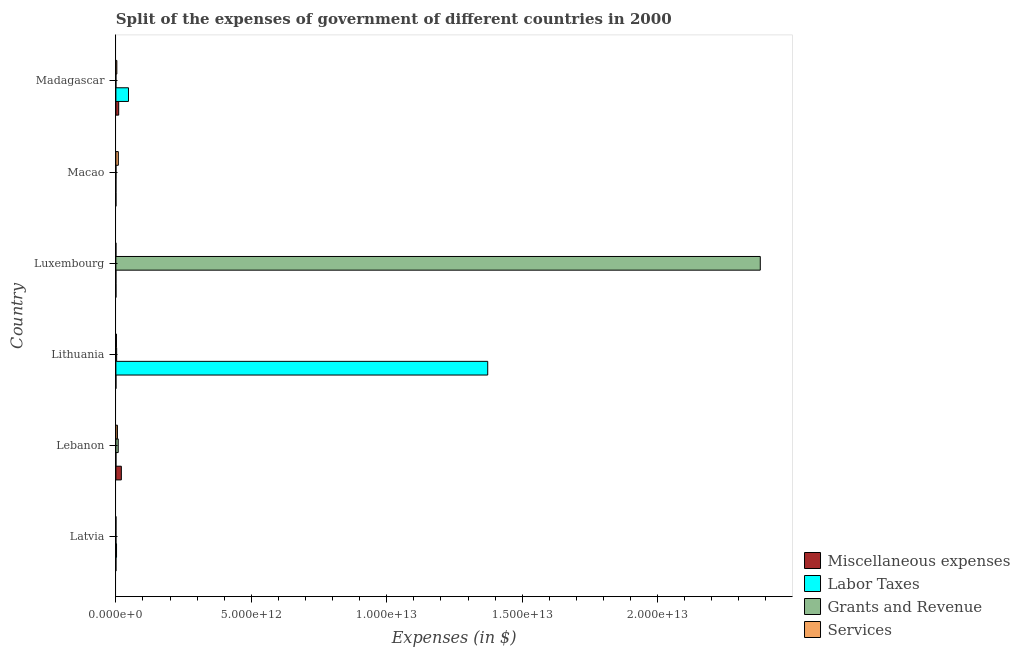How many different coloured bars are there?
Offer a terse response. 4. How many groups of bars are there?
Offer a very short reply. 6. What is the label of the 6th group of bars from the top?
Offer a terse response. Latvia. What is the amount spent on miscellaneous expenses in Madagascar?
Provide a succinct answer. 1.03e+11. Across all countries, what is the maximum amount spent on services?
Your answer should be very brief. 9.03e+1. In which country was the amount spent on services maximum?
Keep it short and to the point. Macao. In which country was the amount spent on miscellaneous expenses minimum?
Keep it short and to the point. Latvia. What is the total amount spent on grants and revenue in the graph?
Your response must be concise. 2.39e+13. What is the difference between the amount spent on services in Latvia and that in Lebanon?
Your answer should be compact. -5.52e+1. What is the difference between the amount spent on services in Latvia and the amount spent on labor taxes in Madagascar?
Keep it short and to the point. -4.63e+11. What is the average amount spent on services per country?
Make the answer very short. 3.40e+1. What is the difference between the amount spent on grants and revenue and amount spent on services in Macao?
Your answer should be very brief. -8.81e+1. What is the ratio of the amount spent on grants and revenue in Latvia to that in Lithuania?
Your answer should be compact. 0.02. Is the amount spent on services in Lithuania less than that in Madagascar?
Offer a terse response. Yes. Is the difference between the amount spent on grants and revenue in Latvia and Lithuania greater than the difference between the amount spent on services in Latvia and Lithuania?
Your response must be concise. No. What is the difference between the highest and the second highest amount spent on labor taxes?
Your response must be concise. 1.33e+13. What is the difference between the highest and the lowest amount spent on miscellaneous expenses?
Offer a very short reply. 2.01e+11. In how many countries, is the amount spent on services greater than the average amount spent on services taken over all countries?
Provide a succinct answer. 3. Is the sum of the amount spent on services in Latvia and Luxembourg greater than the maximum amount spent on grants and revenue across all countries?
Your answer should be very brief. No. Is it the case that in every country, the sum of the amount spent on grants and revenue and amount spent on services is greater than the sum of amount spent on labor taxes and amount spent on miscellaneous expenses?
Offer a very short reply. No. What does the 2nd bar from the top in Lithuania represents?
Your answer should be very brief. Grants and Revenue. What does the 1st bar from the bottom in Madagascar represents?
Provide a short and direct response. Miscellaneous expenses. How many bars are there?
Provide a short and direct response. 24. How many countries are there in the graph?
Your answer should be very brief. 6. What is the difference between two consecutive major ticks on the X-axis?
Your answer should be compact. 5.00e+12. Where does the legend appear in the graph?
Provide a succinct answer. Bottom right. What is the title of the graph?
Offer a very short reply. Split of the expenses of government of different countries in 2000. Does "Overall level" appear as one of the legend labels in the graph?
Ensure brevity in your answer.  No. What is the label or title of the X-axis?
Make the answer very short. Expenses (in $). What is the label or title of the Y-axis?
Offer a very short reply. Country. What is the Expenses (in $) of Miscellaneous expenses in Latvia?
Your response must be concise. 6.00e+07. What is the Expenses (in $) of Labor Taxes in Latvia?
Provide a succinct answer. 2.39e+1. What is the Expenses (in $) of Grants and Revenue in Latvia?
Your answer should be compact. 6.04e+08. What is the Expenses (in $) in Services in Latvia?
Your answer should be very brief. 1.85e+09. What is the Expenses (in $) of Miscellaneous expenses in Lebanon?
Offer a terse response. 2.01e+11. What is the Expenses (in $) of Labor Taxes in Lebanon?
Ensure brevity in your answer.  8.72e+08. What is the Expenses (in $) in Grants and Revenue in Lebanon?
Offer a very short reply. 8.59e+1. What is the Expenses (in $) of Services in Lebanon?
Offer a very short reply. 5.70e+1. What is the Expenses (in $) of Miscellaneous expenses in Lithuania?
Your answer should be compact. 1.35e+09. What is the Expenses (in $) of Labor Taxes in Lithuania?
Keep it short and to the point. 1.37e+13. What is the Expenses (in $) of Grants and Revenue in Lithuania?
Your answer should be compact. 2.80e+1. What is the Expenses (in $) in Services in Lithuania?
Keep it short and to the point. 2.03e+1. What is the Expenses (in $) of Miscellaneous expenses in Luxembourg?
Keep it short and to the point. 9.61e+08. What is the Expenses (in $) in Labor Taxes in Luxembourg?
Give a very brief answer. 2.00e+05. What is the Expenses (in $) in Grants and Revenue in Luxembourg?
Keep it short and to the point. 2.38e+13. What is the Expenses (in $) in Services in Luxembourg?
Offer a very short reply. 1.02e+08. What is the Expenses (in $) of Miscellaneous expenses in Macao?
Provide a succinct answer. 1.19e+09. What is the Expenses (in $) in Grants and Revenue in Macao?
Ensure brevity in your answer.  2.19e+09. What is the Expenses (in $) of Services in Macao?
Your answer should be compact. 9.03e+1. What is the Expenses (in $) in Miscellaneous expenses in Madagascar?
Provide a short and direct response. 1.03e+11. What is the Expenses (in $) in Labor Taxes in Madagascar?
Offer a terse response. 4.65e+11. What is the Expenses (in $) of Grants and Revenue in Madagascar?
Your response must be concise. 1.68e+08. What is the Expenses (in $) in Services in Madagascar?
Offer a very short reply. 3.46e+1. Across all countries, what is the maximum Expenses (in $) of Miscellaneous expenses?
Provide a succinct answer. 2.01e+11. Across all countries, what is the maximum Expenses (in $) of Labor Taxes?
Give a very brief answer. 1.37e+13. Across all countries, what is the maximum Expenses (in $) of Grants and Revenue?
Your response must be concise. 2.38e+13. Across all countries, what is the maximum Expenses (in $) in Services?
Keep it short and to the point. 9.03e+1. Across all countries, what is the minimum Expenses (in $) of Miscellaneous expenses?
Give a very brief answer. 6.00e+07. Across all countries, what is the minimum Expenses (in $) in Grants and Revenue?
Your answer should be very brief. 1.68e+08. Across all countries, what is the minimum Expenses (in $) in Services?
Provide a succinct answer. 1.02e+08. What is the total Expenses (in $) in Miscellaneous expenses in the graph?
Your response must be concise. 3.08e+11. What is the total Expenses (in $) of Labor Taxes in the graph?
Offer a terse response. 1.42e+13. What is the total Expenses (in $) of Grants and Revenue in the graph?
Your answer should be compact. 2.39e+13. What is the total Expenses (in $) of Services in the graph?
Keep it short and to the point. 2.04e+11. What is the difference between the Expenses (in $) of Miscellaneous expenses in Latvia and that in Lebanon?
Give a very brief answer. -2.01e+11. What is the difference between the Expenses (in $) in Labor Taxes in Latvia and that in Lebanon?
Offer a terse response. 2.30e+1. What is the difference between the Expenses (in $) of Grants and Revenue in Latvia and that in Lebanon?
Offer a very short reply. -8.53e+1. What is the difference between the Expenses (in $) in Services in Latvia and that in Lebanon?
Offer a very short reply. -5.52e+1. What is the difference between the Expenses (in $) in Miscellaneous expenses in Latvia and that in Lithuania?
Provide a short and direct response. -1.29e+09. What is the difference between the Expenses (in $) in Labor Taxes in Latvia and that in Lithuania?
Your answer should be compact. -1.37e+13. What is the difference between the Expenses (in $) of Grants and Revenue in Latvia and that in Lithuania?
Give a very brief answer. -2.74e+1. What is the difference between the Expenses (in $) of Services in Latvia and that in Lithuania?
Provide a succinct answer. -1.85e+1. What is the difference between the Expenses (in $) in Miscellaneous expenses in Latvia and that in Luxembourg?
Give a very brief answer. -9.01e+08. What is the difference between the Expenses (in $) in Labor Taxes in Latvia and that in Luxembourg?
Keep it short and to the point. 2.39e+1. What is the difference between the Expenses (in $) of Grants and Revenue in Latvia and that in Luxembourg?
Offer a very short reply. -2.38e+13. What is the difference between the Expenses (in $) in Services in Latvia and that in Luxembourg?
Your answer should be compact. 1.75e+09. What is the difference between the Expenses (in $) of Miscellaneous expenses in Latvia and that in Macao?
Your answer should be very brief. -1.13e+09. What is the difference between the Expenses (in $) in Labor Taxes in Latvia and that in Macao?
Offer a very short reply. 2.39e+1. What is the difference between the Expenses (in $) of Grants and Revenue in Latvia and that in Macao?
Ensure brevity in your answer.  -1.59e+09. What is the difference between the Expenses (in $) in Services in Latvia and that in Macao?
Ensure brevity in your answer.  -8.84e+1. What is the difference between the Expenses (in $) of Miscellaneous expenses in Latvia and that in Madagascar?
Provide a succinct answer. -1.03e+11. What is the difference between the Expenses (in $) in Labor Taxes in Latvia and that in Madagascar?
Keep it short and to the point. -4.41e+11. What is the difference between the Expenses (in $) in Grants and Revenue in Latvia and that in Madagascar?
Your response must be concise. 4.36e+08. What is the difference between the Expenses (in $) of Services in Latvia and that in Madagascar?
Offer a terse response. -3.28e+1. What is the difference between the Expenses (in $) of Miscellaneous expenses in Lebanon and that in Lithuania?
Make the answer very short. 2.00e+11. What is the difference between the Expenses (in $) of Labor Taxes in Lebanon and that in Lithuania?
Your answer should be very brief. -1.37e+13. What is the difference between the Expenses (in $) in Grants and Revenue in Lebanon and that in Lithuania?
Ensure brevity in your answer.  5.80e+1. What is the difference between the Expenses (in $) in Services in Lebanon and that in Lithuania?
Ensure brevity in your answer.  3.67e+1. What is the difference between the Expenses (in $) of Miscellaneous expenses in Lebanon and that in Luxembourg?
Make the answer very short. 2.00e+11. What is the difference between the Expenses (in $) of Labor Taxes in Lebanon and that in Luxembourg?
Your answer should be compact. 8.72e+08. What is the difference between the Expenses (in $) in Grants and Revenue in Lebanon and that in Luxembourg?
Keep it short and to the point. -2.37e+13. What is the difference between the Expenses (in $) of Services in Lebanon and that in Luxembourg?
Your answer should be very brief. 5.69e+1. What is the difference between the Expenses (in $) of Miscellaneous expenses in Lebanon and that in Macao?
Your response must be concise. 2.00e+11. What is the difference between the Expenses (in $) of Labor Taxes in Lebanon and that in Macao?
Ensure brevity in your answer.  8.72e+08. What is the difference between the Expenses (in $) of Grants and Revenue in Lebanon and that in Macao?
Give a very brief answer. 8.37e+1. What is the difference between the Expenses (in $) of Services in Lebanon and that in Macao?
Provide a short and direct response. -3.32e+1. What is the difference between the Expenses (in $) of Miscellaneous expenses in Lebanon and that in Madagascar?
Provide a short and direct response. 9.79e+1. What is the difference between the Expenses (in $) of Labor Taxes in Lebanon and that in Madagascar?
Your response must be concise. -4.64e+11. What is the difference between the Expenses (in $) in Grants and Revenue in Lebanon and that in Madagascar?
Keep it short and to the point. 8.57e+1. What is the difference between the Expenses (in $) in Services in Lebanon and that in Madagascar?
Give a very brief answer. 2.24e+1. What is the difference between the Expenses (in $) in Miscellaneous expenses in Lithuania and that in Luxembourg?
Keep it short and to the point. 3.90e+08. What is the difference between the Expenses (in $) of Labor Taxes in Lithuania and that in Luxembourg?
Offer a very short reply. 1.37e+13. What is the difference between the Expenses (in $) of Grants and Revenue in Lithuania and that in Luxembourg?
Make the answer very short. -2.38e+13. What is the difference between the Expenses (in $) in Services in Lithuania and that in Luxembourg?
Keep it short and to the point. 2.02e+1. What is the difference between the Expenses (in $) in Miscellaneous expenses in Lithuania and that in Macao?
Provide a succinct answer. 1.65e+08. What is the difference between the Expenses (in $) in Labor Taxes in Lithuania and that in Macao?
Offer a very short reply. 1.37e+13. What is the difference between the Expenses (in $) of Grants and Revenue in Lithuania and that in Macao?
Keep it short and to the point. 2.58e+1. What is the difference between the Expenses (in $) in Services in Lithuania and that in Macao?
Your response must be concise. -6.99e+1. What is the difference between the Expenses (in $) of Miscellaneous expenses in Lithuania and that in Madagascar?
Provide a succinct answer. -1.02e+11. What is the difference between the Expenses (in $) of Labor Taxes in Lithuania and that in Madagascar?
Keep it short and to the point. 1.33e+13. What is the difference between the Expenses (in $) in Grants and Revenue in Lithuania and that in Madagascar?
Keep it short and to the point. 2.78e+1. What is the difference between the Expenses (in $) in Services in Lithuania and that in Madagascar?
Your answer should be very brief. -1.43e+1. What is the difference between the Expenses (in $) of Miscellaneous expenses in Luxembourg and that in Macao?
Provide a succinct answer. -2.25e+08. What is the difference between the Expenses (in $) of Labor Taxes in Luxembourg and that in Macao?
Provide a succinct answer. -3.00e+04. What is the difference between the Expenses (in $) of Grants and Revenue in Luxembourg and that in Macao?
Keep it short and to the point. 2.38e+13. What is the difference between the Expenses (in $) of Services in Luxembourg and that in Macao?
Your answer should be very brief. -9.01e+1. What is the difference between the Expenses (in $) in Miscellaneous expenses in Luxembourg and that in Madagascar?
Make the answer very short. -1.02e+11. What is the difference between the Expenses (in $) in Labor Taxes in Luxembourg and that in Madagascar?
Make the answer very short. -4.65e+11. What is the difference between the Expenses (in $) in Grants and Revenue in Luxembourg and that in Madagascar?
Your response must be concise. 2.38e+13. What is the difference between the Expenses (in $) of Services in Luxembourg and that in Madagascar?
Make the answer very short. -3.45e+1. What is the difference between the Expenses (in $) of Miscellaneous expenses in Macao and that in Madagascar?
Keep it short and to the point. -1.02e+11. What is the difference between the Expenses (in $) of Labor Taxes in Macao and that in Madagascar?
Provide a succinct answer. -4.65e+11. What is the difference between the Expenses (in $) of Grants and Revenue in Macao and that in Madagascar?
Provide a short and direct response. 2.02e+09. What is the difference between the Expenses (in $) in Services in Macao and that in Madagascar?
Provide a succinct answer. 5.56e+1. What is the difference between the Expenses (in $) of Miscellaneous expenses in Latvia and the Expenses (in $) of Labor Taxes in Lebanon?
Provide a short and direct response. -8.12e+08. What is the difference between the Expenses (in $) of Miscellaneous expenses in Latvia and the Expenses (in $) of Grants and Revenue in Lebanon?
Offer a terse response. -8.59e+1. What is the difference between the Expenses (in $) of Miscellaneous expenses in Latvia and the Expenses (in $) of Services in Lebanon?
Offer a terse response. -5.70e+1. What is the difference between the Expenses (in $) of Labor Taxes in Latvia and the Expenses (in $) of Grants and Revenue in Lebanon?
Provide a succinct answer. -6.21e+1. What is the difference between the Expenses (in $) of Labor Taxes in Latvia and the Expenses (in $) of Services in Lebanon?
Provide a short and direct response. -3.32e+1. What is the difference between the Expenses (in $) of Grants and Revenue in Latvia and the Expenses (in $) of Services in Lebanon?
Give a very brief answer. -5.64e+1. What is the difference between the Expenses (in $) in Miscellaneous expenses in Latvia and the Expenses (in $) in Labor Taxes in Lithuania?
Your answer should be very brief. -1.37e+13. What is the difference between the Expenses (in $) of Miscellaneous expenses in Latvia and the Expenses (in $) of Grants and Revenue in Lithuania?
Offer a terse response. -2.79e+1. What is the difference between the Expenses (in $) of Miscellaneous expenses in Latvia and the Expenses (in $) of Services in Lithuania?
Keep it short and to the point. -2.03e+1. What is the difference between the Expenses (in $) of Labor Taxes in Latvia and the Expenses (in $) of Grants and Revenue in Lithuania?
Make the answer very short. -4.10e+09. What is the difference between the Expenses (in $) in Labor Taxes in Latvia and the Expenses (in $) in Services in Lithuania?
Provide a short and direct response. 3.54e+09. What is the difference between the Expenses (in $) in Grants and Revenue in Latvia and the Expenses (in $) in Services in Lithuania?
Your answer should be compact. -1.97e+1. What is the difference between the Expenses (in $) in Miscellaneous expenses in Latvia and the Expenses (in $) in Labor Taxes in Luxembourg?
Make the answer very short. 5.98e+07. What is the difference between the Expenses (in $) in Miscellaneous expenses in Latvia and the Expenses (in $) in Grants and Revenue in Luxembourg?
Provide a short and direct response. -2.38e+13. What is the difference between the Expenses (in $) of Miscellaneous expenses in Latvia and the Expenses (in $) of Services in Luxembourg?
Offer a terse response. -4.24e+07. What is the difference between the Expenses (in $) of Labor Taxes in Latvia and the Expenses (in $) of Grants and Revenue in Luxembourg?
Make the answer very short. -2.38e+13. What is the difference between the Expenses (in $) in Labor Taxes in Latvia and the Expenses (in $) in Services in Luxembourg?
Offer a terse response. 2.38e+1. What is the difference between the Expenses (in $) of Grants and Revenue in Latvia and the Expenses (in $) of Services in Luxembourg?
Your answer should be compact. 5.02e+08. What is the difference between the Expenses (in $) in Miscellaneous expenses in Latvia and the Expenses (in $) in Labor Taxes in Macao?
Offer a very short reply. 5.98e+07. What is the difference between the Expenses (in $) in Miscellaneous expenses in Latvia and the Expenses (in $) in Grants and Revenue in Macao?
Your answer should be compact. -2.13e+09. What is the difference between the Expenses (in $) in Miscellaneous expenses in Latvia and the Expenses (in $) in Services in Macao?
Ensure brevity in your answer.  -9.02e+1. What is the difference between the Expenses (in $) of Labor Taxes in Latvia and the Expenses (in $) of Grants and Revenue in Macao?
Ensure brevity in your answer.  2.17e+1. What is the difference between the Expenses (in $) in Labor Taxes in Latvia and the Expenses (in $) in Services in Macao?
Offer a very short reply. -6.64e+1. What is the difference between the Expenses (in $) of Grants and Revenue in Latvia and the Expenses (in $) of Services in Macao?
Your answer should be compact. -8.96e+1. What is the difference between the Expenses (in $) in Miscellaneous expenses in Latvia and the Expenses (in $) in Labor Taxes in Madagascar?
Provide a short and direct response. -4.65e+11. What is the difference between the Expenses (in $) of Miscellaneous expenses in Latvia and the Expenses (in $) of Grants and Revenue in Madagascar?
Your answer should be compact. -1.07e+08. What is the difference between the Expenses (in $) in Miscellaneous expenses in Latvia and the Expenses (in $) in Services in Madagascar?
Provide a short and direct response. -3.46e+1. What is the difference between the Expenses (in $) of Labor Taxes in Latvia and the Expenses (in $) of Grants and Revenue in Madagascar?
Give a very brief answer. 2.37e+1. What is the difference between the Expenses (in $) of Labor Taxes in Latvia and the Expenses (in $) of Services in Madagascar?
Your response must be concise. -1.08e+1. What is the difference between the Expenses (in $) of Grants and Revenue in Latvia and the Expenses (in $) of Services in Madagascar?
Your answer should be very brief. -3.40e+1. What is the difference between the Expenses (in $) of Miscellaneous expenses in Lebanon and the Expenses (in $) of Labor Taxes in Lithuania?
Your response must be concise. -1.35e+13. What is the difference between the Expenses (in $) of Miscellaneous expenses in Lebanon and the Expenses (in $) of Grants and Revenue in Lithuania?
Offer a very short reply. 1.73e+11. What is the difference between the Expenses (in $) in Miscellaneous expenses in Lebanon and the Expenses (in $) in Services in Lithuania?
Your answer should be very brief. 1.81e+11. What is the difference between the Expenses (in $) of Labor Taxes in Lebanon and the Expenses (in $) of Grants and Revenue in Lithuania?
Offer a very short reply. -2.71e+1. What is the difference between the Expenses (in $) of Labor Taxes in Lebanon and the Expenses (in $) of Services in Lithuania?
Your answer should be very brief. -1.95e+1. What is the difference between the Expenses (in $) of Grants and Revenue in Lebanon and the Expenses (in $) of Services in Lithuania?
Keep it short and to the point. 6.56e+1. What is the difference between the Expenses (in $) of Miscellaneous expenses in Lebanon and the Expenses (in $) of Labor Taxes in Luxembourg?
Give a very brief answer. 2.01e+11. What is the difference between the Expenses (in $) in Miscellaneous expenses in Lebanon and the Expenses (in $) in Grants and Revenue in Luxembourg?
Ensure brevity in your answer.  -2.36e+13. What is the difference between the Expenses (in $) of Miscellaneous expenses in Lebanon and the Expenses (in $) of Services in Luxembourg?
Ensure brevity in your answer.  2.01e+11. What is the difference between the Expenses (in $) of Labor Taxes in Lebanon and the Expenses (in $) of Grants and Revenue in Luxembourg?
Offer a very short reply. -2.38e+13. What is the difference between the Expenses (in $) of Labor Taxes in Lebanon and the Expenses (in $) of Services in Luxembourg?
Offer a very short reply. 7.70e+08. What is the difference between the Expenses (in $) in Grants and Revenue in Lebanon and the Expenses (in $) in Services in Luxembourg?
Give a very brief answer. 8.58e+1. What is the difference between the Expenses (in $) in Miscellaneous expenses in Lebanon and the Expenses (in $) in Labor Taxes in Macao?
Provide a short and direct response. 2.01e+11. What is the difference between the Expenses (in $) of Miscellaneous expenses in Lebanon and the Expenses (in $) of Grants and Revenue in Macao?
Your response must be concise. 1.99e+11. What is the difference between the Expenses (in $) of Miscellaneous expenses in Lebanon and the Expenses (in $) of Services in Macao?
Make the answer very short. 1.11e+11. What is the difference between the Expenses (in $) in Labor Taxes in Lebanon and the Expenses (in $) in Grants and Revenue in Macao?
Offer a terse response. -1.32e+09. What is the difference between the Expenses (in $) of Labor Taxes in Lebanon and the Expenses (in $) of Services in Macao?
Your answer should be compact. -8.94e+1. What is the difference between the Expenses (in $) in Grants and Revenue in Lebanon and the Expenses (in $) in Services in Macao?
Your response must be concise. -4.34e+09. What is the difference between the Expenses (in $) in Miscellaneous expenses in Lebanon and the Expenses (in $) in Labor Taxes in Madagascar?
Make the answer very short. -2.64e+11. What is the difference between the Expenses (in $) of Miscellaneous expenses in Lebanon and the Expenses (in $) of Grants and Revenue in Madagascar?
Keep it short and to the point. 2.01e+11. What is the difference between the Expenses (in $) of Miscellaneous expenses in Lebanon and the Expenses (in $) of Services in Madagascar?
Make the answer very short. 1.67e+11. What is the difference between the Expenses (in $) in Labor Taxes in Lebanon and the Expenses (in $) in Grants and Revenue in Madagascar?
Provide a short and direct response. 7.05e+08. What is the difference between the Expenses (in $) in Labor Taxes in Lebanon and the Expenses (in $) in Services in Madagascar?
Ensure brevity in your answer.  -3.38e+1. What is the difference between the Expenses (in $) in Grants and Revenue in Lebanon and the Expenses (in $) in Services in Madagascar?
Provide a short and direct response. 5.13e+1. What is the difference between the Expenses (in $) of Miscellaneous expenses in Lithuania and the Expenses (in $) of Labor Taxes in Luxembourg?
Give a very brief answer. 1.35e+09. What is the difference between the Expenses (in $) of Miscellaneous expenses in Lithuania and the Expenses (in $) of Grants and Revenue in Luxembourg?
Provide a succinct answer. -2.38e+13. What is the difference between the Expenses (in $) of Miscellaneous expenses in Lithuania and the Expenses (in $) of Services in Luxembourg?
Provide a succinct answer. 1.25e+09. What is the difference between the Expenses (in $) of Labor Taxes in Lithuania and the Expenses (in $) of Grants and Revenue in Luxembourg?
Provide a succinct answer. -1.01e+13. What is the difference between the Expenses (in $) of Labor Taxes in Lithuania and the Expenses (in $) of Services in Luxembourg?
Your answer should be compact. 1.37e+13. What is the difference between the Expenses (in $) in Grants and Revenue in Lithuania and the Expenses (in $) in Services in Luxembourg?
Offer a terse response. 2.79e+1. What is the difference between the Expenses (in $) in Miscellaneous expenses in Lithuania and the Expenses (in $) in Labor Taxes in Macao?
Your answer should be very brief. 1.35e+09. What is the difference between the Expenses (in $) of Miscellaneous expenses in Lithuania and the Expenses (in $) of Grants and Revenue in Macao?
Offer a very short reply. -8.39e+08. What is the difference between the Expenses (in $) of Miscellaneous expenses in Lithuania and the Expenses (in $) of Services in Macao?
Your answer should be very brief. -8.89e+1. What is the difference between the Expenses (in $) of Labor Taxes in Lithuania and the Expenses (in $) of Grants and Revenue in Macao?
Offer a very short reply. 1.37e+13. What is the difference between the Expenses (in $) in Labor Taxes in Lithuania and the Expenses (in $) in Services in Macao?
Give a very brief answer. 1.36e+13. What is the difference between the Expenses (in $) of Grants and Revenue in Lithuania and the Expenses (in $) of Services in Macao?
Make the answer very short. -6.23e+1. What is the difference between the Expenses (in $) in Miscellaneous expenses in Lithuania and the Expenses (in $) in Labor Taxes in Madagascar?
Your answer should be very brief. -4.64e+11. What is the difference between the Expenses (in $) in Miscellaneous expenses in Lithuania and the Expenses (in $) in Grants and Revenue in Madagascar?
Provide a succinct answer. 1.18e+09. What is the difference between the Expenses (in $) in Miscellaneous expenses in Lithuania and the Expenses (in $) in Services in Madagascar?
Offer a very short reply. -3.33e+1. What is the difference between the Expenses (in $) of Labor Taxes in Lithuania and the Expenses (in $) of Grants and Revenue in Madagascar?
Offer a terse response. 1.37e+13. What is the difference between the Expenses (in $) in Labor Taxes in Lithuania and the Expenses (in $) in Services in Madagascar?
Keep it short and to the point. 1.37e+13. What is the difference between the Expenses (in $) in Grants and Revenue in Lithuania and the Expenses (in $) in Services in Madagascar?
Make the answer very short. -6.67e+09. What is the difference between the Expenses (in $) of Miscellaneous expenses in Luxembourg and the Expenses (in $) of Labor Taxes in Macao?
Offer a terse response. 9.61e+08. What is the difference between the Expenses (in $) in Miscellaneous expenses in Luxembourg and the Expenses (in $) in Grants and Revenue in Macao?
Your answer should be very brief. -1.23e+09. What is the difference between the Expenses (in $) in Miscellaneous expenses in Luxembourg and the Expenses (in $) in Services in Macao?
Offer a terse response. -8.93e+1. What is the difference between the Expenses (in $) in Labor Taxes in Luxembourg and the Expenses (in $) in Grants and Revenue in Macao?
Ensure brevity in your answer.  -2.19e+09. What is the difference between the Expenses (in $) in Labor Taxes in Luxembourg and the Expenses (in $) in Services in Macao?
Make the answer very short. -9.03e+1. What is the difference between the Expenses (in $) in Grants and Revenue in Luxembourg and the Expenses (in $) in Services in Macao?
Give a very brief answer. 2.37e+13. What is the difference between the Expenses (in $) in Miscellaneous expenses in Luxembourg and the Expenses (in $) in Labor Taxes in Madagascar?
Make the answer very short. -4.64e+11. What is the difference between the Expenses (in $) in Miscellaneous expenses in Luxembourg and the Expenses (in $) in Grants and Revenue in Madagascar?
Offer a very short reply. 7.93e+08. What is the difference between the Expenses (in $) in Miscellaneous expenses in Luxembourg and the Expenses (in $) in Services in Madagascar?
Your answer should be compact. -3.37e+1. What is the difference between the Expenses (in $) in Labor Taxes in Luxembourg and the Expenses (in $) in Grants and Revenue in Madagascar?
Give a very brief answer. -1.67e+08. What is the difference between the Expenses (in $) of Labor Taxes in Luxembourg and the Expenses (in $) of Services in Madagascar?
Offer a terse response. -3.46e+1. What is the difference between the Expenses (in $) of Grants and Revenue in Luxembourg and the Expenses (in $) of Services in Madagascar?
Provide a short and direct response. 2.38e+13. What is the difference between the Expenses (in $) of Miscellaneous expenses in Macao and the Expenses (in $) of Labor Taxes in Madagascar?
Make the answer very short. -4.64e+11. What is the difference between the Expenses (in $) of Miscellaneous expenses in Macao and the Expenses (in $) of Grants and Revenue in Madagascar?
Make the answer very short. 1.02e+09. What is the difference between the Expenses (in $) of Miscellaneous expenses in Macao and the Expenses (in $) of Services in Madagascar?
Your answer should be compact. -3.34e+1. What is the difference between the Expenses (in $) of Labor Taxes in Macao and the Expenses (in $) of Grants and Revenue in Madagascar?
Your answer should be very brief. -1.67e+08. What is the difference between the Expenses (in $) in Labor Taxes in Macao and the Expenses (in $) in Services in Madagascar?
Keep it short and to the point. -3.46e+1. What is the difference between the Expenses (in $) in Grants and Revenue in Macao and the Expenses (in $) in Services in Madagascar?
Ensure brevity in your answer.  -3.24e+1. What is the average Expenses (in $) of Miscellaneous expenses per country?
Make the answer very short. 5.14e+1. What is the average Expenses (in $) in Labor Taxes per country?
Your response must be concise. 2.37e+12. What is the average Expenses (in $) in Grants and Revenue per country?
Offer a terse response. 3.98e+12. What is the average Expenses (in $) in Services per country?
Provide a short and direct response. 3.40e+1. What is the difference between the Expenses (in $) of Miscellaneous expenses and Expenses (in $) of Labor Taxes in Latvia?
Your answer should be very brief. -2.38e+1. What is the difference between the Expenses (in $) in Miscellaneous expenses and Expenses (in $) in Grants and Revenue in Latvia?
Provide a short and direct response. -5.44e+08. What is the difference between the Expenses (in $) of Miscellaneous expenses and Expenses (in $) of Services in Latvia?
Provide a short and direct response. -1.79e+09. What is the difference between the Expenses (in $) of Labor Taxes and Expenses (in $) of Grants and Revenue in Latvia?
Give a very brief answer. 2.33e+1. What is the difference between the Expenses (in $) of Labor Taxes and Expenses (in $) of Services in Latvia?
Your answer should be compact. 2.20e+1. What is the difference between the Expenses (in $) of Grants and Revenue and Expenses (in $) of Services in Latvia?
Provide a succinct answer. -1.25e+09. What is the difference between the Expenses (in $) in Miscellaneous expenses and Expenses (in $) in Labor Taxes in Lebanon?
Provide a short and direct response. 2.01e+11. What is the difference between the Expenses (in $) of Miscellaneous expenses and Expenses (in $) of Grants and Revenue in Lebanon?
Offer a very short reply. 1.15e+11. What is the difference between the Expenses (in $) in Miscellaneous expenses and Expenses (in $) in Services in Lebanon?
Your response must be concise. 1.44e+11. What is the difference between the Expenses (in $) in Labor Taxes and Expenses (in $) in Grants and Revenue in Lebanon?
Offer a very short reply. -8.50e+1. What is the difference between the Expenses (in $) in Labor Taxes and Expenses (in $) in Services in Lebanon?
Provide a succinct answer. -5.61e+1. What is the difference between the Expenses (in $) of Grants and Revenue and Expenses (in $) of Services in Lebanon?
Make the answer very short. 2.89e+1. What is the difference between the Expenses (in $) in Miscellaneous expenses and Expenses (in $) in Labor Taxes in Lithuania?
Your response must be concise. -1.37e+13. What is the difference between the Expenses (in $) of Miscellaneous expenses and Expenses (in $) of Grants and Revenue in Lithuania?
Offer a very short reply. -2.66e+1. What is the difference between the Expenses (in $) in Miscellaneous expenses and Expenses (in $) in Services in Lithuania?
Your response must be concise. -1.90e+1. What is the difference between the Expenses (in $) in Labor Taxes and Expenses (in $) in Grants and Revenue in Lithuania?
Provide a short and direct response. 1.37e+13. What is the difference between the Expenses (in $) of Labor Taxes and Expenses (in $) of Services in Lithuania?
Give a very brief answer. 1.37e+13. What is the difference between the Expenses (in $) in Grants and Revenue and Expenses (in $) in Services in Lithuania?
Your response must be concise. 7.63e+09. What is the difference between the Expenses (in $) of Miscellaneous expenses and Expenses (in $) of Labor Taxes in Luxembourg?
Make the answer very short. 9.61e+08. What is the difference between the Expenses (in $) of Miscellaneous expenses and Expenses (in $) of Grants and Revenue in Luxembourg?
Provide a succinct answer. -2.38e+13. What is the difference between the Expenses (in $) of Miscellaneous expenses and Expenses (in $) of Services in Luxembourg?
Give a very brief answer. 8.58e+08. What is the difference between the Expenses (in $) in Labor Taxes and Expenses (in $) in Grants and Revenue in Luxembourg?
Your answer should be compact. -2.38e+13. What is the difference between the Expenses (in $) in Labor Taxes and Expenses (in $) in Services in Luxembourg?
Your answer should be compact. -1.02e+08. What is the difference between the Expenses (in $) in Grants and Revenue and Expenses (in $) in Services in Luxembourg?
Offer a very short reply. 2.38e+13. What is the difference between the Expenses (in $) of Miscellaneous expenses and Expenses (in $) of Labor Taxes in Macao?
Provide a succinct answer. 1.19e+09. What is the difference between the Expenses (in $) in Miscellaneous expenses and Expenses (in $) in Grants and Revenue in Macao?
Make the answer very short. -1.00e+09. What is the difference between the Expenses (in $) in Miscellaneous expenses and Expenses (in $) in Services in Macao?
Give a very brief answer. -8.91e+1. What is the difference between the Expenses (in $) of Labor Taxes and Expenses (in $) of Grants and Revenue in Macao?
Offer a terse response. -2.19e+09. What is the difference between the Expenses (in $) of Labor Taxes and Expenses (in $) of Services in Macao?
Your answer should be very brief. -9.03e+1. What is the difference between the Expenses (in $) of Grants and Revenue and Expenses (in $) of Services in Macao?
Give a very brief answer. -8.81e+1. What is the difference between the Expenses (in $) in Miscellaneous expenses and Expenses (in $) in Labor Taxes in Madagascar?
Provide a succinct answer. -3.62e+11. What is the difference between the Expenses (in $) in Miscellaneous expenses and Expenses (in $) in Grants and Revenue in Madagascar?
Provide a succinct answer. 1.03e+11. What is the difference between the Expenses (in $) in Miscellaneous expenses and Expenses (in $) in Services in Madagascar?
Ensure brevity in your answer.  6.88e+1. What is the difference between the Expenses (in $) of Labor Taxes and Expenses (in $) of Grants and Revenue in Madagascar?
Give a very brief answer. 4.65e+11. What is the difference between the Expenses (in $) of Labor Taxes and Expenses (in $) of Services in Madagascar?
Your answer should be very brief. 4.31e+11. What is the difference between the Expenses (in $) of Grants and Revenue and Expenses (in $) of Services in Madagascar?
Provide a short and direct response. -3.45e+1. What is the ratio of the Expenses (in $) of Miscellaneous expenses in Latvia to that in Lebanon?
Offer a terse response. 0. What is the ratio of the Expenses (in $) of Labor Taxes in Latvia to that in Lebanon?
Ensure brevity in your answer.  27.36. What is the ratio of the Expenses (in $) of Grants and Revenue in Latvia to that in Lebanon?
Your answer should be compact. 0.01. What is the ratio of the Expenses (in $) of Services in Latvia to that in Lebanon?
Give a very brief answer. 0.03. What is the ratio of the Expenses (in $) in Miscellaneous expenses in Latvia to that in Lithuania?
Provide a short and direct response. 0.04. What is the ratio of the Expenses (in $) of Labor Taxes in Latvia to that in Lithuania?
Make the answer very short. 0. What is the ratio of the Expenses (in $) in Grants and Revenue in Latvia to that in Lithuania?
Give a very brief answer. 0.02. What is the ratio of the Expenses (in $) in Services in Latvia to that in Lithuania?
Offer a terse response. 0.09. What is the ratio of the Expenses (in $) in Miscellaneous expenses in Latvia to that in Luxembourg?
Keep it short and to the point. 0.06. What is the ratio of the Expenses (in $) in Labor Taxes in Latvia to that in Luxembourg?
Keep it short and to the point. 1.19e+05. What is the ratio of the Expenses (in $) of Services in Latvia to that in Luxembourg?
Your answer should be very brief. 18.09. What is the ratio of the Expenses (in $) in Miscellaneous expenses in Latvia to that in Macao?
Your answer should be compact. 0.05. What is the ratio of the Expenses (in $) in Labor Taxes in Latvia to that in Macao?
Your answer should be compact. 1.04e+05. What is the ratio of the Expenses (in $) of Grants and Revenue in Latvia to that in Macao?
Provide a succinct answer. 0.28. What is the ratio of the Expenses (in $) of Services in Latvia to that in Macao?
Give a very brief answer. 0.02. What is the ratio of the Expenses (in $) of Miscellaneous expenses in Latvia to that in Madagascar?
Your answer should be compact. 0. What is the ratio of the Expenses (in $) of Labor Taxes in Latvia to that in Madagascar?
Ensure brevity in your answer.  0.05. What is the ratio of the Expenses (in $) in Grants and Revenue in Latvia to that in Madagascar?
Ensure brevity in your answer.  3.61. What is the ratio of the Expenses (in $) of Services in Latvia to that in Madagascar?
Ensure brevity in your answer.  0.05. What is the ratio of the Expenses (in $) of Miscellaneous expenses in Lebanon to that in Lithuania?
Provide a succinct answer. 149.15. What is the ratio of the Expenses (in $) in Labor Taxes in Lebanon to that in Lithuania?
Your response must be concise. 0. What is the ratio of the Expenses (in $) in Grants and Revenue in Lebanon to that in Lithuania?
Offer a very short reply. 3.07. What is the ratio of the Expenses (in $) in Services in Lebanon to that in Lithuania?
Keep it short and to the point. 2.8. What is the ratio of the Expenses (in $) in Miscellaneous expenses in Lebanon to that in Luxembourg?
Give a very brief answer. 209.62. What is the ratio of the Expenses (in $) in Labor Taxes in Lebanon to that in Luxembourg?
Give a very brief answer. 4361.33. What is the ratio of the Expenses (in $) of Grants and Revenue in Lebanon to that in Luxembourg?
Your response must be concise. 0. What is the ratio of the Expenses (in $) of Services in Lebanon to that in Luxembourg?
Make the answer very short. 556.42. What is the ratio of the Expenses (in $) of Miscellaneous expenses in Lebanon to that in Macao?
Provide a succinct answer. 169.86. What is the ratio of the Expenses (in $) of Labor Taxes in Lebanon to that in Macao?
Make the answer very short. 3792.46. What is the ratio of the Expenses (in $) of Grants and Revenue in Lebanon to that in Macao?
Give a very brief answer. 39.24. What is the ratio of the Expenses (in $) in Services in Lebanon to that in Macao?
Keep it short and to the point. 0.63. What is the ratio of the Expenses (in $) in Miscellaneous expenses in Lebanon to that in Madagascar?
Offer a very short reply. 1.95. What is the ratio of the Expenses (in $) of Labor Taxes in Lebanon to that in Madagascar?
Make the answer very short. 0. What is the ratio of the Expenses (in $) of Grants and Revenue in Lebanon to that in Madagascar?
Ensure brevity in your answer.  512.93. What is the ratio of the Expenses (in $) of Services in Lebanon to that in Madagascar?
Offer a terse response. 1.65. What is the ratio of the Expenses (in $) in Miscellaneous expenses in Lithuania to that in Luxembourg?
Offer a terse response. 1.41. What is the ratio of the Expenses (in $) in Labor Taxes in Lithuania to that in Luxembourg?
Provide a short and direct response. 6.86e+07. What is the ratio of the Expenses (in $) in Grants and Revenue in Lithuania to that in Luxembourg?
Your answer should be compact. 0. What is the ratio of the Expenses (in $) of Services in Lithuania to that in Luxembourg?
Keep it short and to the point. 198.39. What is the ratio of the Expenses (in $) in Miscellaneous expenses in Lithuania to that in Macao?
Provide a succinct answer. 1.14. What is the ratio of the Expenses (in $) of Labor Taxes in Lithuania to that in Macao?
Make the answer very short. 5.97e+07. What is the ratio of the Expenses (in $) of Grants and Revenue in Lithuania to that in Macao?
Make the answer very short. 12.77. What is the ratio of the Expenses (in $) in Services in Lithuania to that in Macao?
Make the answer very short. 0.23. What is the ratio of the Expenses (in $) of Miscellaneous expenses in Lithuania to that in Madagascar?
Make the answer very short. 0.01. What is the ratio of the Expenses (in $) in Labor Taxes in Lithuania to that in Madagascar?
Your answer should be compact. 29.51. What is the ratio of the Expenses (in $) of Grants and Revenue in Lithuania to that in Madagascar?
Your answer should be very brief. 166.95. What is the ratio of the Expenses (in $) in Services in Lithuania to that in Madagascar?
Offer a very short reply. 0.59. What is the ratio of the Expenses (in $) of Miscellaneous expenses in Luxembourg to that in Macao?
Provide a short and direct response. 0.81. What is the ratio of the Expenses (in $) in Labor Taxes in Luxembourg to that in Macao?
Ensure brevity in your answer.  0.87. What is the ratio of the Expenses (in $) in Grants and Revenue in Luxembourg to that in Macao?
Provide a short and direct response. 1.09e+04. What is the ratio of the Expenses (in $) in Services in Luxembourg to that in Macao?
Ensure brevity in your answer.  0. What is the ratio of the Expenses (in $) of Miscellaneous expenses in Luxembourg to that in Madagascar?
Your answer should be very brief. 0.01. What is the ratio of the Expenses (in $) of Labor Taxes in Luxembourg to that in Madagascar?
Give a very brief answer. 0. What is the ratio of the Expenses (in $) of Grants and Revenue in Luxembourg to that in Madagascar?
Provide a short and direct response. 1.42e+05. What is the ratio of the Expenses (in $) in Services in Luxembourg to that in Madagascar?
Ensure brevity in your answer.  0. What is the ratio of the Expenses (in $) of Miscellaneous expenses in Macao to that in Madagascar?
Keep it short and to the point. 0.01. What is the ratio of the Expenses (in $) of Labor Taxes in Macao to that in Madagascar?
Ensure brevity in your answer.  0. What is the ratio of the Expenses (in $) in Grants and Revenue in Macao to that in Madagascar?
Give a very brief answer. 13.07. What is the ratio of the Expenses (in $) of Services in Macao to that in Madagascar?
Give a very brief answer. 2.61. What is the difference between the highest and the second highest Expenses (in $) in Miscellaneous expenses?
Your answer should be very brief. 9.79e+1. What is the difference between the highest and the second highest Expenses (in $) of Labor Taxes?
Provide a succinct answer. 1.33e+13. What is the difference between the highest and the second highest Expenses (in $) of Grants and Revenue?
Give a very brief answer. 2.37e+13. What is the difference between the highest and the second highest Expenses (in $) in Services?
Your answer should be very brief. 3.32e+1. What is the difference between the highest and the lowest Expenses (in $) in Miscellaneous expenses?
Offer a very short reply. 2.01e+11. What is the difference between the highest and the lowest Expenses (in $) in Labor Taxes?
Give a very brief answer. 1.37e+13. What is the difference between the highest and the lowest Expenses (in $) in Grants and Revenue?
Your response must be concise. 2.38e+13. What is the difference between the highest and the lowest Expenses (in $) of Services?
Offer a very short reply. 9.01e+1. 